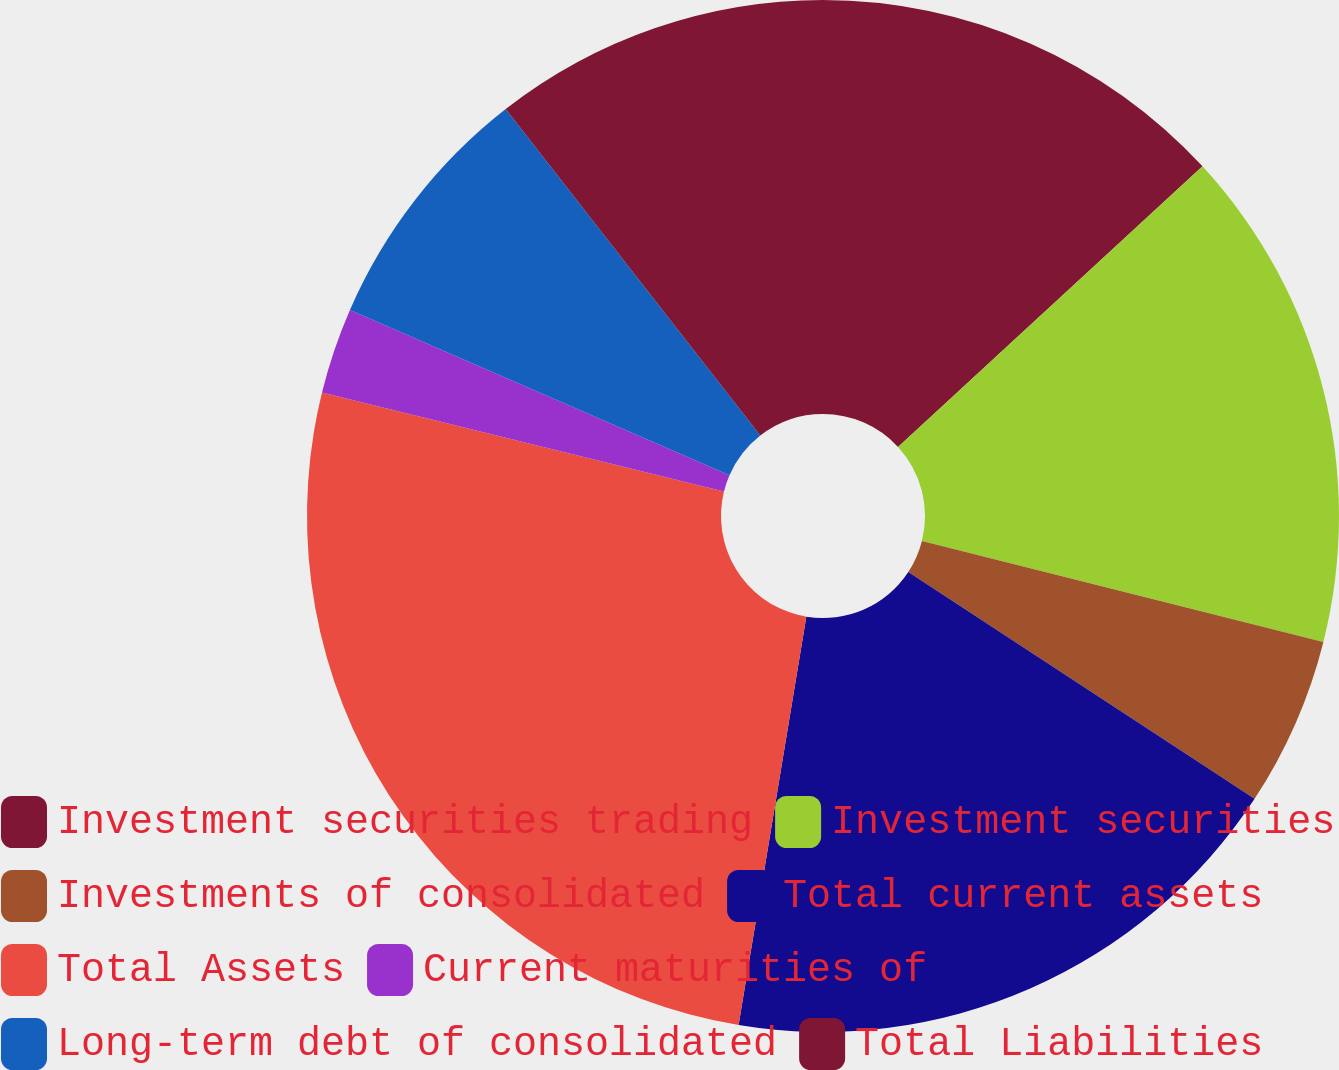Convert chart to OTSL. <chart><loc_0><loc_0><loc_500><loc_500><pie_chart><fcel>Investment securities trading<fcel>Investment securities<fcel>Investments of consolidated<fcel>Total current assets<fcel>Total Assets<fcel>Current maturities of<fcel>Long-term debt of consolidated<fcel>Total Liabilities<nl><fcel>13.15%<fcel>15.77%<fcel>5.31%<fcel>18.38%<fcel>26.23%<fcel>2.69%<fcel>7.92%<fcel>10.54%<nl></chart> 